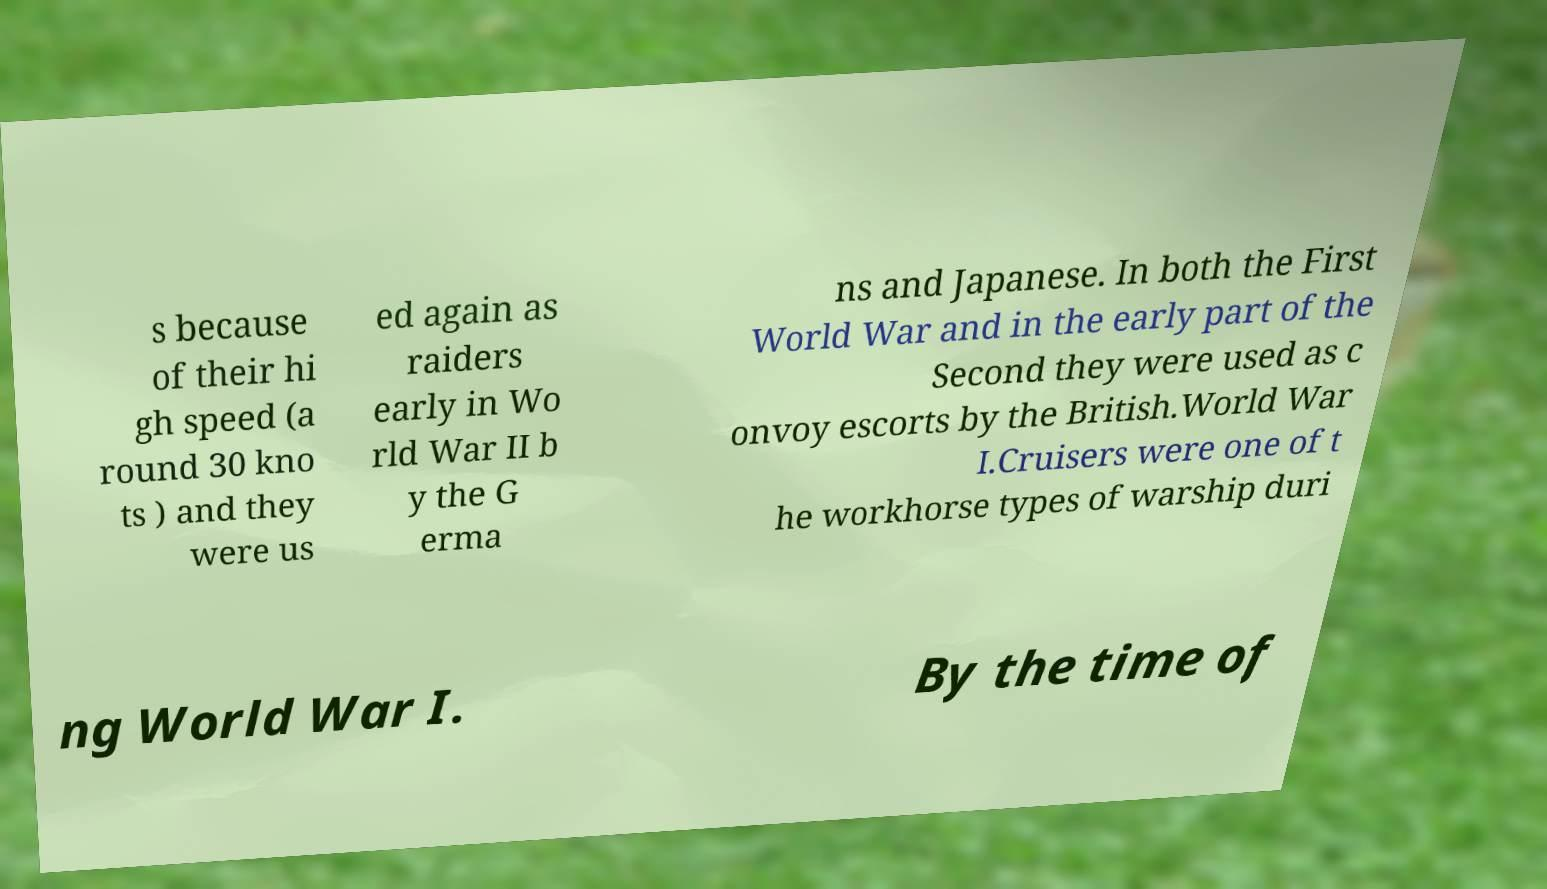Can you accurately transcribe the text from the provided image for me? s because of their hi gh speed (a round 30 kno ts ) and they were us ed again as raiders early in Wo rld War II b y the G erma ns and Japanese. In both the First World War and in the early part of the Second they were used as c onvoy escorts by the British.World War I.Cruisers were one of t he workhorse types of warship duri ng World War I. By the time of 